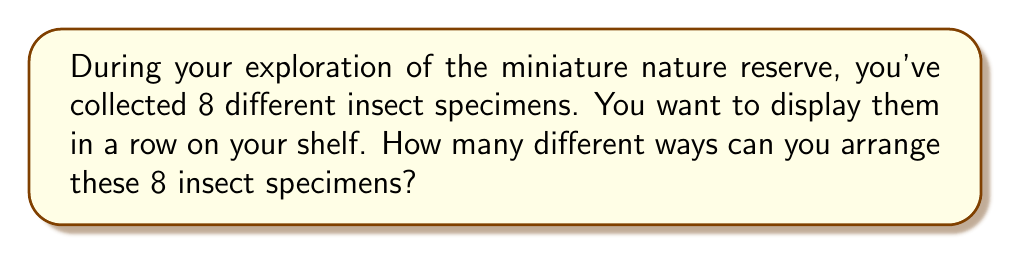Provide a solution to this math problem. Let's approach this step-by-step:

1) This problem is a classic example of a permutation. We are arranging all 8 specimens, and the order matters (since we're displaying them in a row).

2) The formula for permutations of n distinct objects is:

   $$P(n) = n!$$

   Where $n!$ (n factorial) is the product of all positive integers less than or equal to n.

3) In this case, $n = 8$, so we need to calculate $8!$

4) Let's expand this:

   $$8! = 8 \times 7 \times 6 \times 5 \times 4 \times 3 \times 2 \times 1$$

5) Multiplying these numbers:

   $$8! = 40,320$$

Therefore, there are 40,320 different ways to arrange the 8 insect specimens on your shelf.
Answer: $40,320$ 